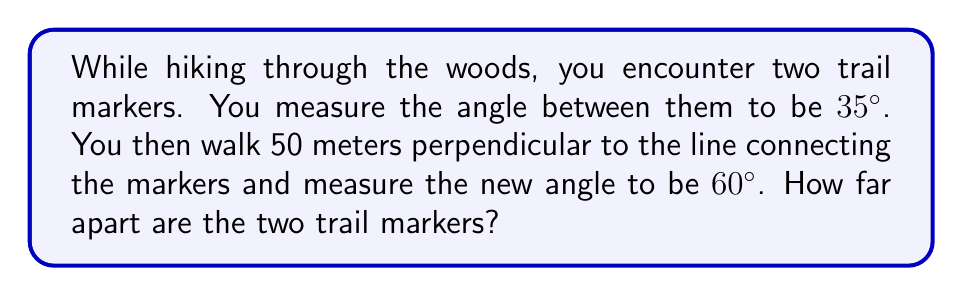Help me with this question. Let's approach this step-by-step using trigonometry:

1) Let's denote the distance between the markers as $x$ meters.

2) We can draw a right triangle where:
   - The hypotenuse is $x$
   - One leg is 50 meters (the perpendicular distance we walked)
   - The angle opposite to the 50m leg is $(60° - 35°) = 25°$

3) In this right triangle, we can use the tangent function:

   $$\tan 25° = \frac{50}{x}$$

4) To solve for $x$, we divide both sides by $\tan 25°$:

   $$x = \frac{50}{\tan 25°}$$

5) Using a calculator or trigonometric table:

   $$x = \frac{50}{\tan 25°} \approx 107.55$$

6) Therefore, the distance between the two trail markers is approximately 107.55 meters.

[asy]
import geometry;

size(200);

pair A = (0,0), B = (107.55,0), C = (107.55,50);
draw(A--B--C--A);

label("A", A, SW);
label("B", B, SE);
label("C", C, NE);

label("50m", (107.55,25), E);
label("x", (53.775,0), S);

draw(arc(A,10,0,35), Arrow);
draw(arc(C,10,180,240), Arrow);

label("35°", (5,5));
label("60°", (102.55,55));
[/asy]
Answer: $107.55$ meters 